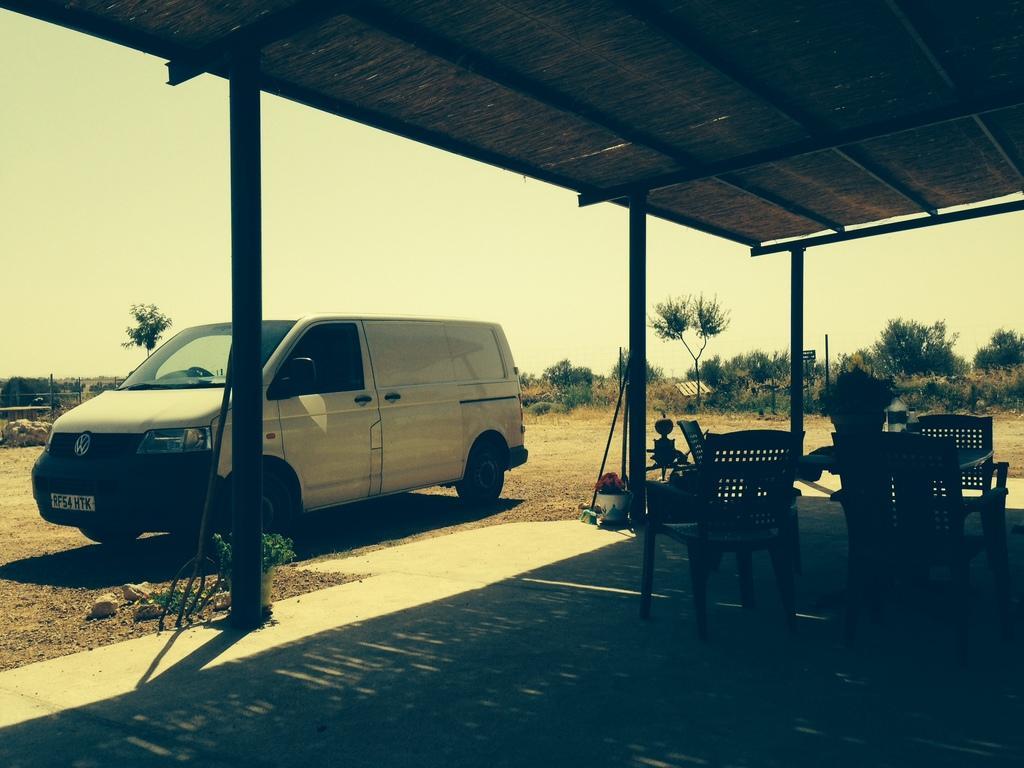How would you summarize this image in a sentence or two? In the picture we can see a shed with some pillars to it and under it we can see some chairs and besides, we can see a van which is white in color and in the background we can see some plants, dried grass and sky. 